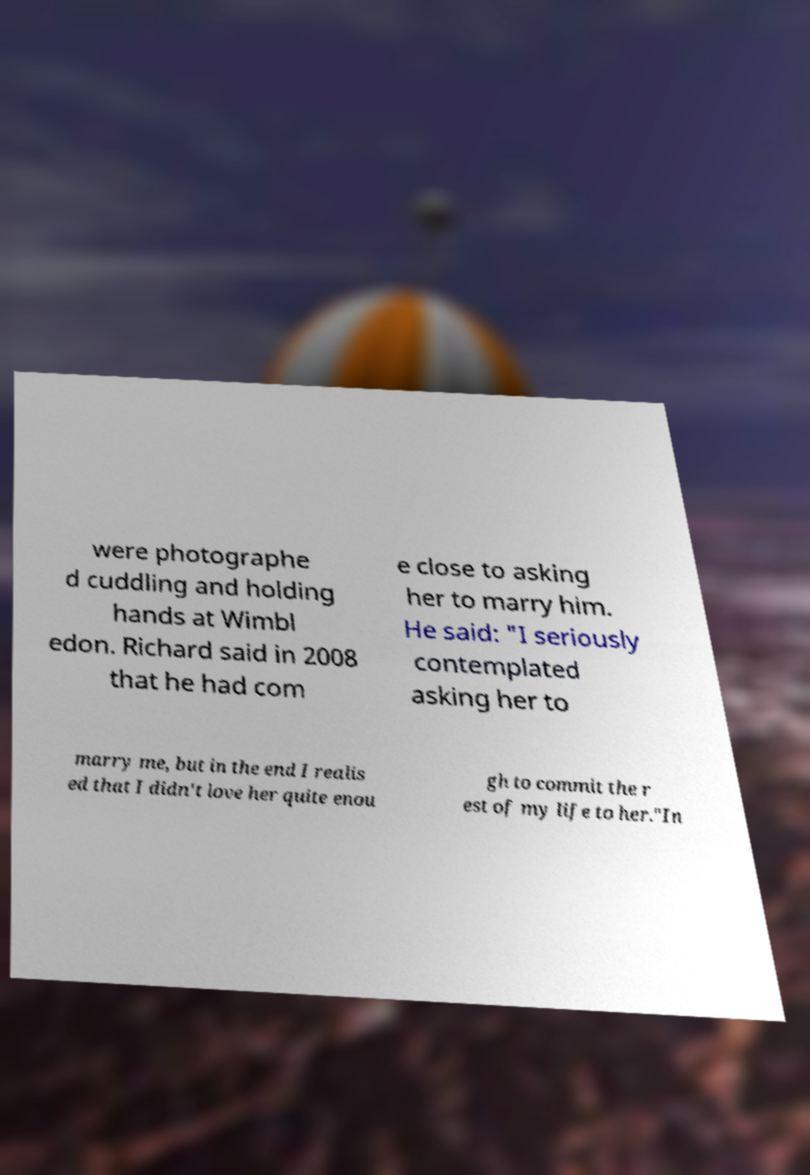There's text embedded in this image that I need extracted. Can you transcribe it verbatim? were photographe d cuddling and holding hands at Wimbl edon. Richard said in 2008 that he had com e close to asking her to marry him. He said: "I seriously contemplated asking her to marry me, but in the end I realis ed that I didn't love her quite enou gh to commit the r est of my life to her."In 